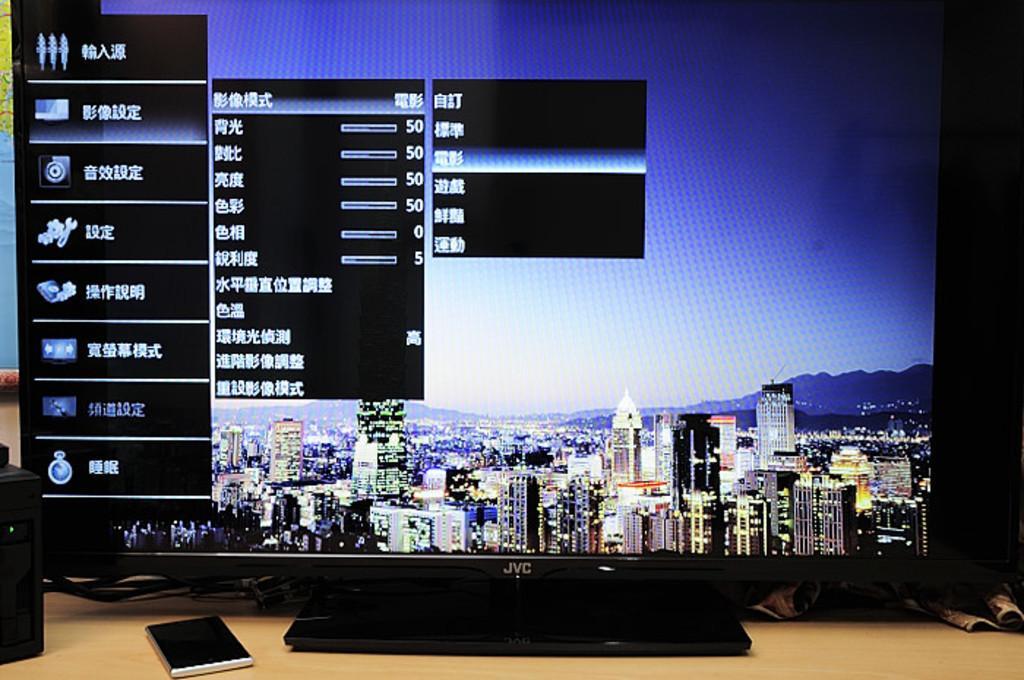Describe this image in one or two sentences. On this table we can see a monitor, book and things. On this monitor screen we can see buildings. 